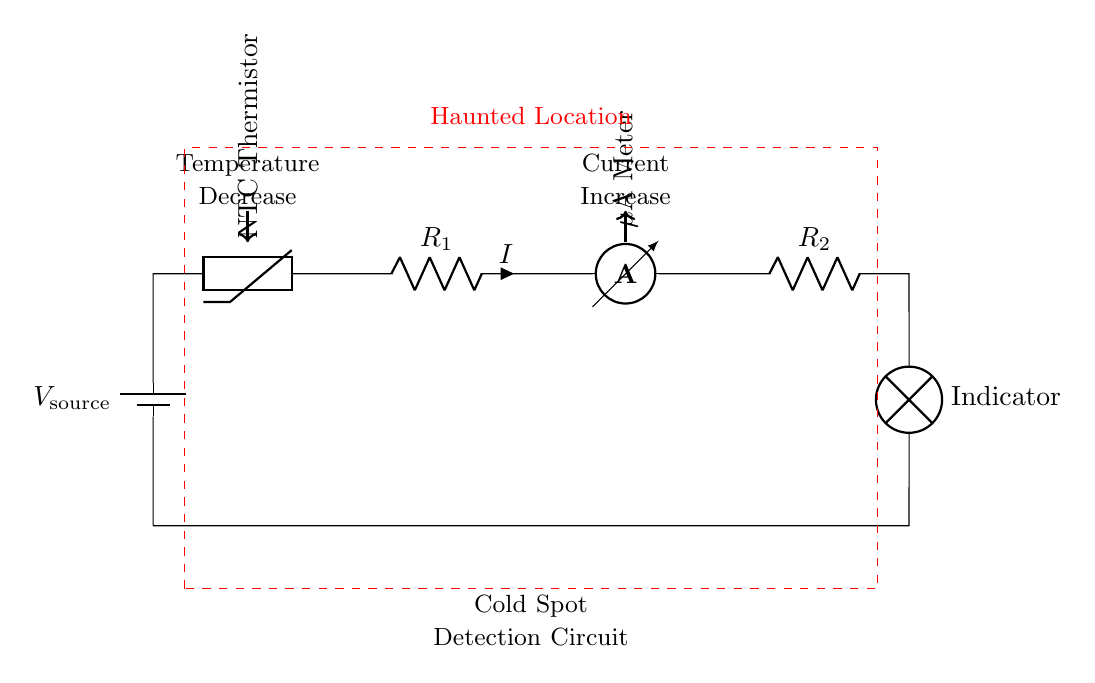What is the main purpose of this circuit? The main purpose of the circuit is to detect cold spots, which are associated with alleged paranormal activity in haunted locations. The NTC thermistor reacts to temperature changes, indicating a dip in temperature.
Answer: Cold spot detection What type of thermistor is used in the circuit? The circuit uses an NTC (Negative Temperature Coefficient) thermistor, which decreases resistance as temperature decreases, allowing it to detect changes in temperature.
Answer: NTC thermistor How does the current behave when the temperature decreases? As the temperature decreases, the resistance of the NTC thermistor also decreases, leading to an increase in current in the circuit. This behavior is due to Ohm's Law, where a lower resistance results in higher current for a constant voltage source.
Answer: Increases What component indicates the presence of a cold spot? The lamp serves as an indicator to show when a cold spot is detected. If the thermistor detects a significant drop in temperature, it changes the circuit conditions, allowing current to flow and lighting the lamp.
Answer: Lamp What role do the resistors play in this circuit? The resistors help control the current flowing through the circuit and assist in setting the operating point of the NTC thermistor for accurate temperature detection. They help stabilize the circuit performance in response to temperature changes.
Answer: Control current What would happen to the lamp if the temperature increases? If the temperature increases, the resistance of the NTC thermistor rises, which decreases the current in the circuit. This could result in the lamp turning off if the current drops below a certain threshold, indicating no cold spot detection.
Answer: Turns off 